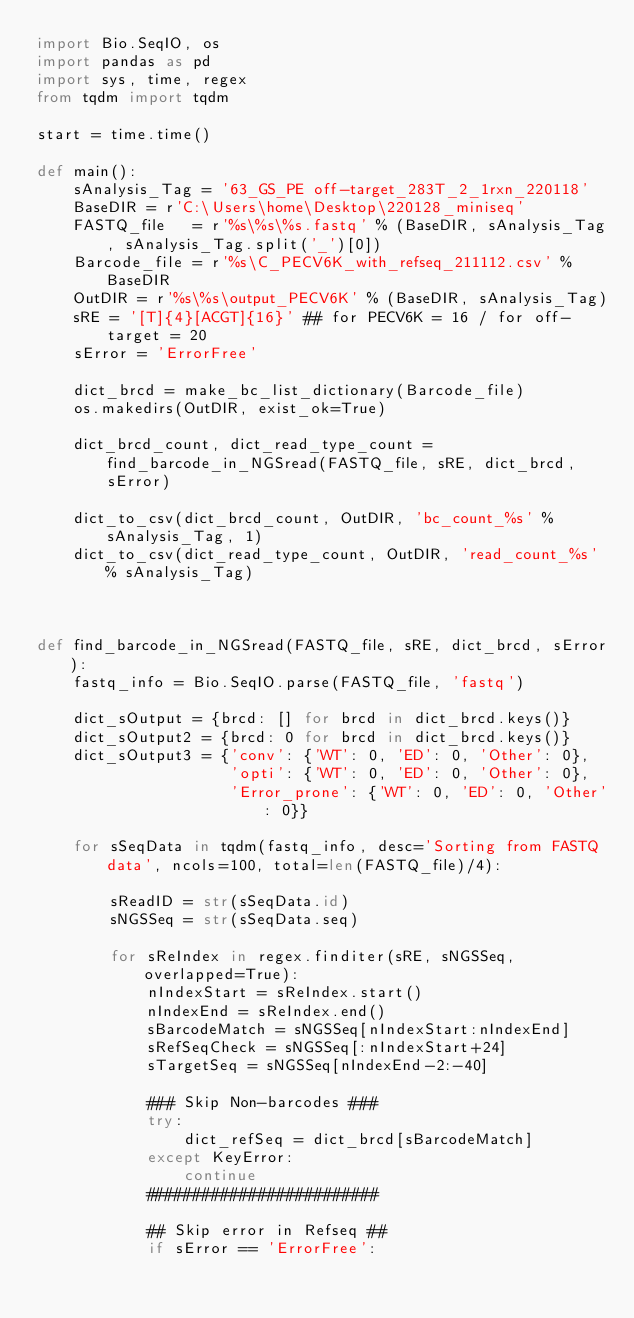<code> <loc_0><loc_0><loc_500><loc_500><_Python_>import Bio.SeqIO, os
import pandas as pd
import sys, time, regex
from tqdm import tqdm

start = time.time()

def main():
    sAnalysis_Tag = '63_GS_PE off-target_283T_2_1rxn_220118'
    BaseDIR = r'C:\Users\home\Desktop\220128_miniseq'
    FASTQ_file   = r'%s\%s\%s.fastq' % (BaseDIR, sAnalysis_Tag, sAnalysis_Tag.split('_')[0])
    Barcode_file = r'%s\C_PECV6K_with_refseq_211112.csv' % BaseDIR
    OutDIR = r'%s\%s\output_PECV6K' % (BaseDIR, sAnalysis_Tag)
    sRE = '[T]{4}[ACGT]{16}' ## for PECV6K = 16 / for off-target = 20
    sError = 'ErrorFree'

    dict_brcd = make_bc_list_dictionary(Barcode_file)
    os.makedirs(OutDIR, exist_ok=True)

    dict_brcd_count, dict_read_type_count = find_barcode_in_NGSread(FASTQ_file, sRE, dict_brcd, sError)

    dict_to_csv(dict_brcd_count, OutDIR, 'bc_count_%s' % sAnalysis_Tag, 1)
    dict_to_csv(dict_read_type_count, OutDIR, 'read_count_%s' % sAnalysis_Tag)



def find_barcode_in_NGSread(FASTQ_file, sRE, dict_brcd, sError):
    fastq_info = Bio.SeqIO.parse(FASTQ_file, 'fastq')

    dict_sOutput = {brcd: [] for brcd in dict_brcd.keys()}
    dict_sOutput2 = {brcd: 0 for brcd in dict_brcd.keys()}
    dict_sOutput3 = {'conv': {'WT': 0, 'ED': 0, 'Other': 0},
                     'opti': {'WT': 0, 'ED': 0, 'Other': 0},
                     'Error_prone': {'WT': 0, 'ED': 0, 'Other': 0}}

    for sSeqData in tqdm(fastq_info, desc='Sorting from FASTQ data', ncols=100, total=len(FASTQ_file)/4):

        sReadID = str(sSeqData.id)
        sNGSSeq = str(sSeqData.seq)

        for sReIndex in regex.finditer(sRE, sNGSSeq, overlapped=True):
            nIndexStart = sReIndex.start()
            nIndexEnd = sReIndex.end()
            sBarcodeMatch = sNGSSeq[nIndexStart:nIndexEnd]
            sRefSeqCheck = sNGSSeq[:nIndexStart+24]
            sTargetSeq = sNGSSeq[nIndexEnd-2:-40]

            ### Skip Non-barcodes ###
            try:
                dict_refSeq = dict_brcd[sBarcodeMatch]
            except KeyError:
                continue
            #########################

            ## Skip error in Refseq ##
            if sError == 'ErrorFree':</code> 